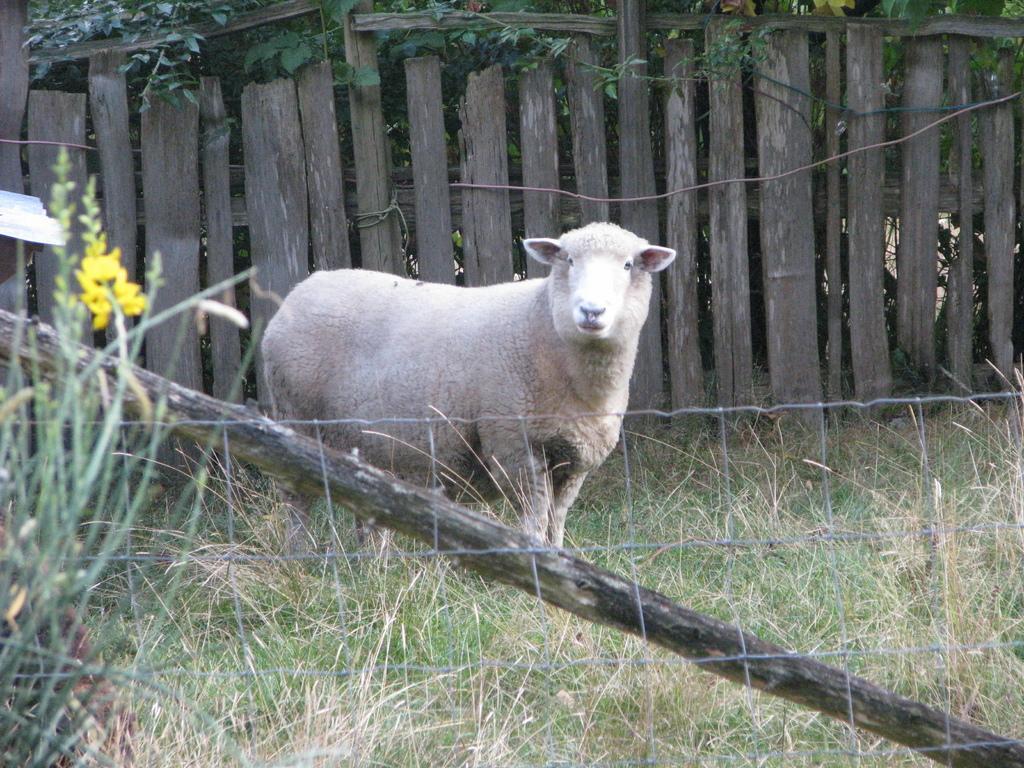Could you give a brief overview of what you see in this image? In this image, a sheep is standing in the middle, there is a wooden wall, in the middle of an image. 